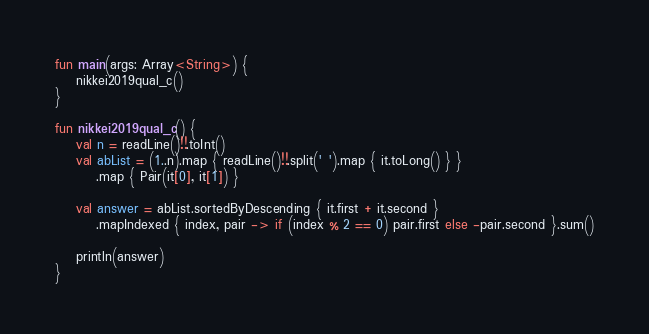<code> <loc_0><loc_0><loc_500><loc_500><_Kotlin_>fun main(args: Array<String>) {
    nikkei2019qual_c()
}

fun nikkei2019qual_c() {
    val n = readLine()!!.toInt()
    val abList = (1..n).map { readLine()!!.split(' ').map { it.toLong() } }
        .map { Pair(it[0], it[1]) }

    val answer = abList.sortedByDescending { it.first + it.second }
        .mapIndexed { index, pair -> if (index % 2 == 0) pair.first else -pair.second }.sum()

    println(answer)
}
</code> 